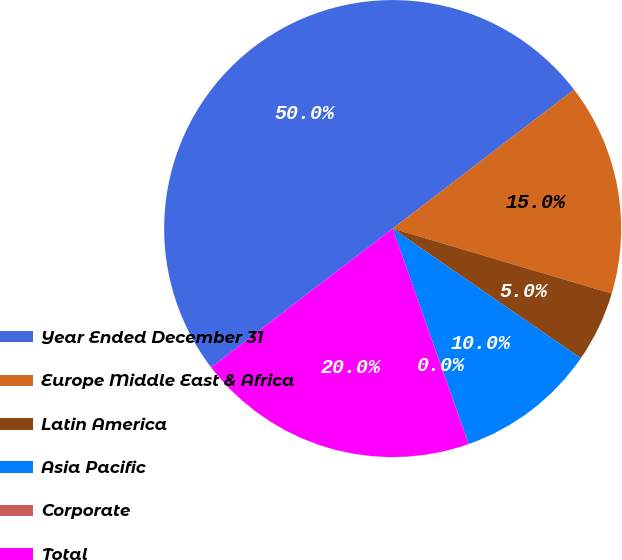Convert chart to OTSL. <chart><loc_0><loc_0><loc_500><loc_500><pie_chart><fcel>Year Ended December 31<fcel>Europe Middle East & Africa<fcel>Latin America<fcel>Asia Pacific<fcel>Corporate<fcel>Total<nl><fcel>49.99%<fcel>15.0%<fcel>5.01%<fcel>10.0%<fcel>0.01%<fcel>20.0%<nl></chart> 